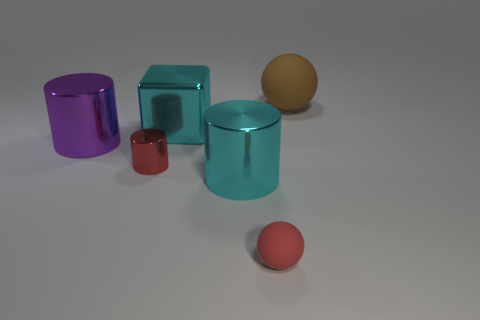Add 1 purple cylinders. How many objects exist? 7 Subtract all spheres. How many objects are left? 4 Add 6 large brown objects. How many large brown objects are left? 7 Add 6 purple shiny things. How many purple shiny things exist? 7 Subtract 0 blue cubes. How many objects are left? 6 Subtract all purple things. Subtract all matte spheres. How many objects are left? 3 